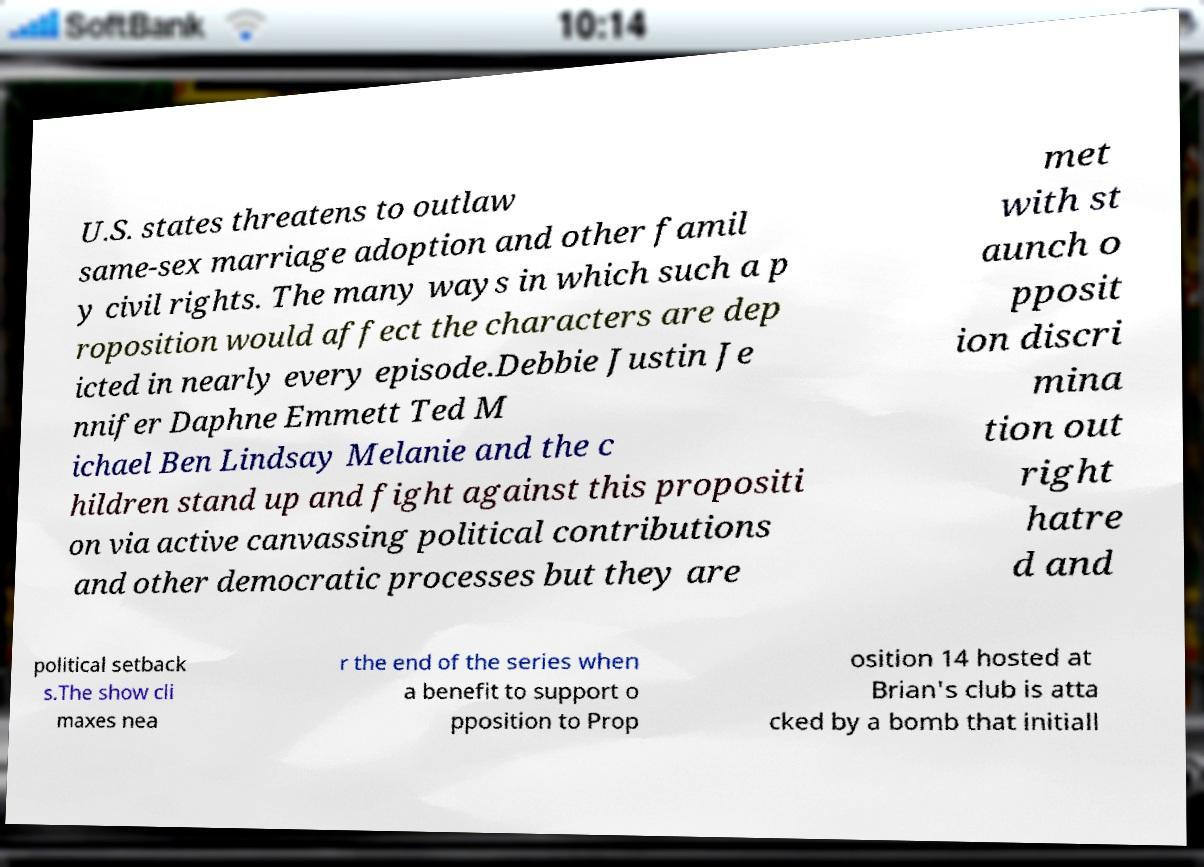Could you extract and type out the text from this image? U.S. states threatens to outlaw same-sex marriage adoption and other famil y civil rights. The many ways in which such a p roposition would affect the characters are dep icted in nearly every episode.Debbie Justin Je nnifer Daphne Emmett Ted M ichael Ben Lindsay Melanie and the c hildren stand up and fight against this propositi on via active canvassing political contributions and other democratic processes but they are met with st aunch o pposit ion discri mina tion out right hatre d and political setback s.The show cli maxes nea r the end of the series when a benefit to support o pposition to Prop osition 14 hosted at Brian's club is atta cked by a bomb that initiall 